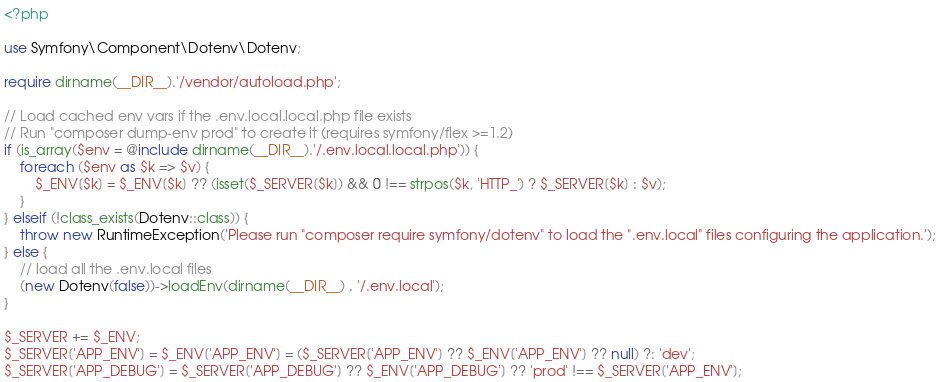Convert code to text. <code><loc_0><loc_0><loc_500><loc_500><_PHP_><?php

use Symfony\Component\Dotenv\Dotenv;

require dirname(__DIR__).'/vendor/autoload.php';

// Load cached env vars if the .env.local.local.php file exists
// Run "composer dump-env prod" to create it (requires symfony/flex >=1.2)
if (is_array($env = @include dirname(__DIR__).'/.env.local.local.php')) {
    foreach ($env as $k => $v) {
        $_ENV[$k] = $_ENV[$k] ?? (isset($_SERVER[$k]) && 0 !== strpos($k, 'HTTP_') ? $_SERVER[$k] : $v);
    }
} elseif (!class_exists(Dotenv::class)) {
    throw new RuntimeException('Please run "composer require symfony/dotenv" to load the ".env.local" files configuring the application.');
} else {
    // load all the .env.local files
    (new Dotenv(false))->loadEnv(dirname(__DIR__) . '/.env.local');
}

$_SERVER += $_ENV;
$_SERVER['APP_ENV'] = $_ENV['APP_ENV'] = ($_SERVER['APP_ENV'] ?? $_ENV['APP_ENV'] ?? null) ?: 'dev';
$_SERVER['APP_DEBUG'] = $_SERVER['APP_DEBUG'] ?? $_ENV['APP_DEBUG'] ?? 'prod' !== $_SERVER['APP_ENV'];</code> 